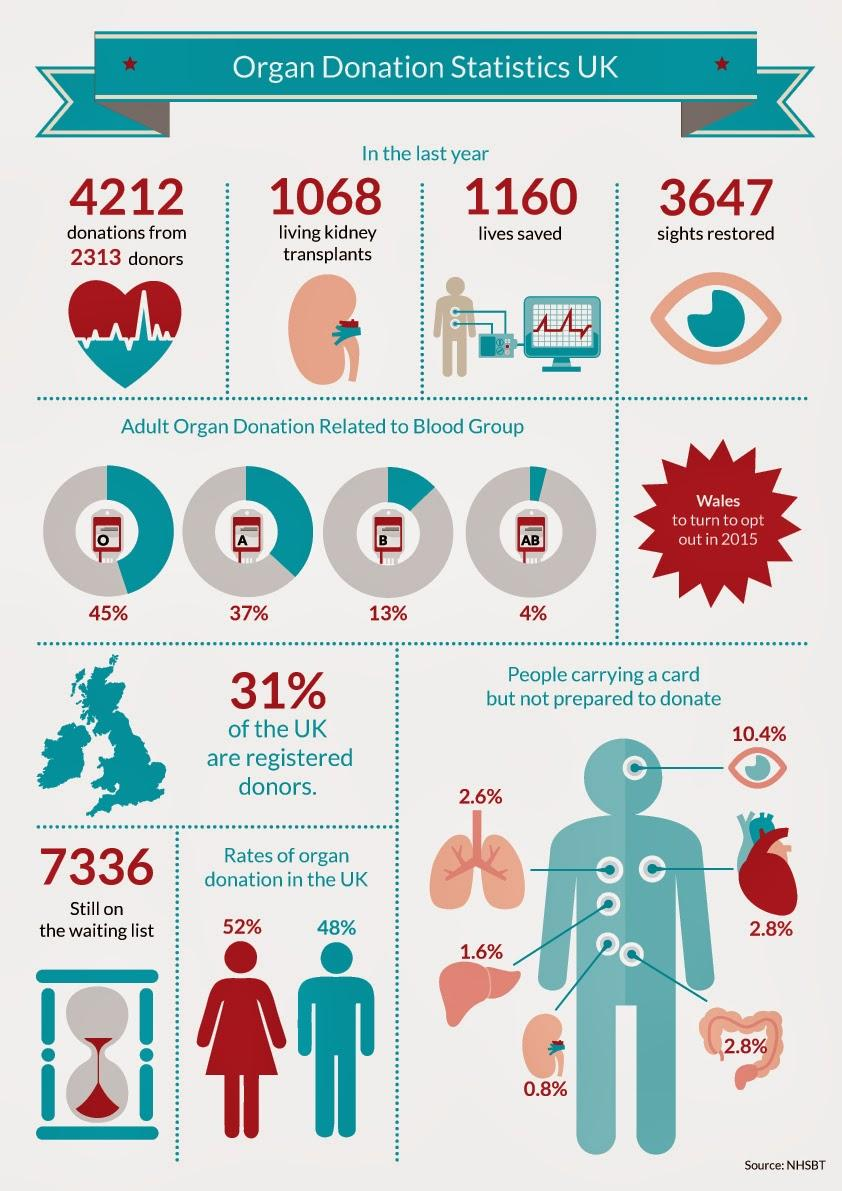Point out several critical features in this image. According to a recent survey, only 0.8% of card holders are not prepared to donate a kidney. The organ shown in the second image is the kidney. It was found that 89.6% of card holders are willing to donate their eyes. According to UK statistics, the majority of organ donors are women. The percentage of organ donation made by people belonging to blood group O is the highest among A, AB, O, and B blood groups. 